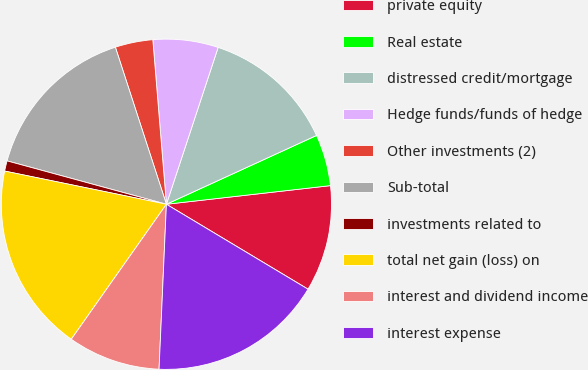<chart> <loc_0><loc_0><loc_500><loc_500><pie_chart><fcel>private equity<fcel>Real estate<fcel>distressed credit/mortgage<fcel>Hedge funds/funds of hedge<fcel>Other investments (2)<fcel>Sub-total<fcel>investments related to<fcel>total net gain (loss) on<fcel>interest and dividend income<fcel>interest expense<nl><fcel>10.4%<fcel>5.04%<fcel>13.09%<fcel>6.38%<fcel>3.69%<fcel>15.77%<fcel>1.01%<fcel>18.45%<fcel>9.06%<fcel>17.11%<nl></chart> 